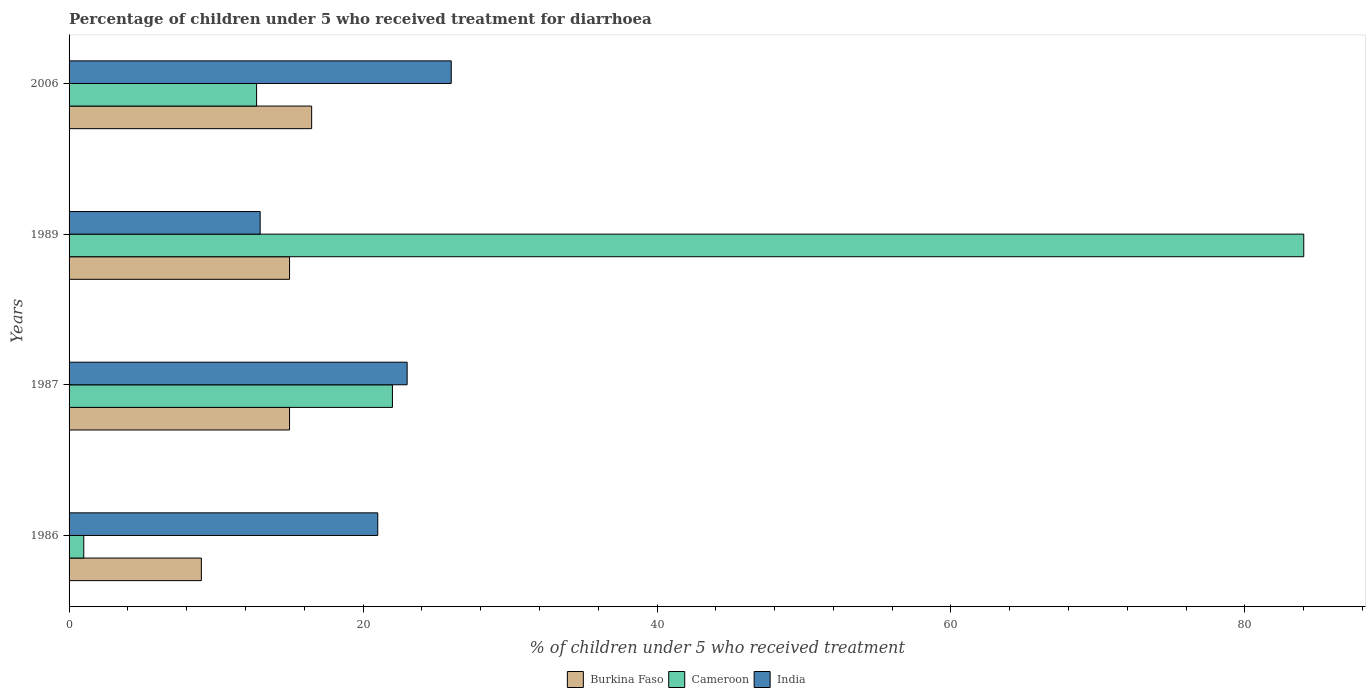Are the number of bars on each tick of the Y-axis equal?
Your answer should be very brief. Yes. How many bars are there on the 3rd tick from the bottom?
Provide a short and direct response. 3. In how many cases, is the number of bars for a given year not equal to the number of legend labels?
Ensure brevity in your answer.  0. Across all years, what is the maximum percentage of children who received treatment for diarrhoea  in Burkina Faso?
Keep it short and to the point. 16.5. Across all years, what is the minimum percentage of children who received treatment for diarrhoea  in Cameroon?
Offer a terse response. 1. In which year was the percentage of children who received treatment for diarrhoea  in India maximum?
Offer a very short reply. 2006. In which year was the percentage of children who received treatment for diarrhoea  in Cameroon minimum?
Provide a short and direct response. 1986. What is the difference between the percentage of children who received treatment for diarrhoea  in Cameroon in 1987 and that in 1989?
Keep it short and to the point. -62. What is the average percentage of children who received treatment for diarrhoea  in Burkina Faso per year?
Your answer should be very brief. 13.88. In how many years, is the percentage of children who received treatment for diarrhoea  in Cameroon greater than 32 %?
Offer a very short reply. 1. What is the ratio of the percentage of children who received treatment for diarrhoea  in Cameroon in 1987 to that in 2006?
Your answer should be compact. 1.72. Is the percentage of children who received treatment for diarrhoea  in Cameroon in 1987 less than that in 2006?
Provide a succinct answer. No. What is the difference between the highest and the second highest percentage of children who received treatment for diarrhoea  in Cameroon?
Make the answer very short. 62. What is the difference between the highest and the lowest percentage of children who received treatment for diarrhoea  in Burkina Faso?
Make the answer very short. 7.5. In how many years, is the percentage of children who received treatment for diarrhoea  in Cameroon greater than the average percentage of children who received treatment for diarrhoea  in Cameroon taken over all years?
Give a very brief answer. 1. What does the 2nd bar from the top in 1989 represents?
Give a very brief answer. Cameroon. What does the 2nd bar from the bottom in 2006 represents?
Ensure brevity in your answer.  Cameroon. Is it the case that in every year, the sum of the percentage of children who received treatment for diarrhoea  in Burkina Faso and percentage of children who received treatment for diarrhoea  in Cameroon is greater than the percentage of children who received treatment for diarrhoea  in India?
Give a very brief answer. No. Are the values on the major ticks of X-axis written in scientific E-notation?
Provide a short and direct response. No. Does the graph contain grids?
Provide a short and direct response. No. What is the title of the graph?
Your answer should be compact. Percentage of children under 5 who received treatment for diarrhoea. Does "Hong Kong" appear as one of the legend labels in the graph?
Give a very brief answer. No. What is the label or title of the X-axis?
Provide a short and direct response. % of children under 5 who received treatment. What is the % of children under 5 who received treatment in Burkina Faso in 1986?
Offer a very short reply. 9. What is the % of children under 5 who received treatment in Cameroon in 1986?
Make the answer very short. 1. What is the % of children under 5 who received treatment of India in 1986?
Give a very brief answer. 21. What is the % of children under 5 who received treatment of Cameroon in 1987?
Your answer should be very brief. 22. What is the % of children under 5 who received treatment of India in 1987?
Provide a succinct answer. 23. What is the % of children under 5 who received treatment in Burkina Faso in 1989?
Provide a short and direct response. 15. What is the % of children under 5 who received treatment of India in 1989?
Your response must be concise. 13. What is the % of children under 5 who received treatment of Burkina Faso in 2006?
Keep it short and to the point. 16.5. What is the % of children under 5 who received treatment of Cameroon in 2006?
Your answer should be very brief. 12.76. What is the % of children under 5 who received treatment in India in 2006?
Your answer should be very brief. 26. Across all years, what is the maximum % of children under 5 who received treatment of Burkina Faso?
Make the answer very short. 16.5. Across all years, what is the maximum % of children under 5 who received treatment in India?
Make the answer very short. 26. Across all years, what is the minimum % of children under 5 who received treatment in Burkina Faso?
Your answer should be compact. 9. Across all years, what is the minimum % of children under 5 who received treatment of Cameroon?
Provide a succinct answer. 1. Across all years, what is the minimum % of children under 5 who received treatment of India?
Give a very brief answer. 13. What is the total % of children under 5 who received treatment of Burkina Faso in the graph?
Your response must be concise. 55.5. What is the total % of children under 5 who received treatment in Cameroon in the graph?
Keep it short and to the point. 119.76. What is the total % of children under 5 who received treatment of India in the graph?
Provide a short and direct response. 83. What is the difference between the % of children under 5 who received treatment in Cameroon in 1986 and that in 1987?
Provide a succinct answer. -21. What is the difference between the % of children under 5 who received treatment in India in 1986 and that in 1987?
Your answer should be very brief. -2. What is the difference between the % of children under 5 who received treatment in Burkina Faso in 1986 and that in 1989?
Your answer should be compact. -6. What is the difference between the % of children under 5 who received treatment in Cameroon in 1986 and that in 1989?
Your answer should be very brief. -83. What is the difference between the % of children under 5 who received treatment in India in 1986 and that in 1989?
Give a very brief answer. 8. What is the difference between the % of children under 5 who received treatment in Burkina Faso in 1986 and that in 2006?
Ensure brevity in your answer.  -7.5. What is the difference between the % of children under 5 who received treatment in Cameroon in 1986 and that in 2006?
Give a very brief answer. -11.76. What is the difference between the % of children under 5 who received treatment in Burkina Faso in 1987 and that in 1989?
Provide a short and direct response. 0. What is the difference between the % of children under 5 who received treatment in Cameroon in 1987 and that in 1989?
Offer a very short reply. -62. What is the difference between the % of children under 5 who received treatment in Burkina Faso in 1987 and that in 2006?
Your response must be concise. -1.5. What is the difference between the % of children under 5 who received treatment of Cameroon in 1987 and that in 2006?
Provide a succinct answer. 9.24. What is the difference between the % of children under 5 who received treatment in India in 1987 and that in 2006?
Ensure brevity in your answer.  -3. What is the difference between the % of children under 5 who received treatment of Burkina Faso in 1989 and that in 2006?
Your answer should be very brief. -1.5. What is the difference between the % of children under 5 who received treatment of Cameroon in 1989 and that in 2006?
Give a very brief answer. 71.24. What is the difference between the % of children under 5 who received treatment in India in 1989 and that in 2006?
Ensure brevity in your answer.  -13. What is the difference between the % of children under 5 who received treatment of Burkina Faso in 1986 and the % of children under 5 who received treatment of India in 1987?
Make the answer very short. -14. What is the difference between the % of children under 5 who received treatment of Cameroon in 1986 and the % of children under 5 who received treatment of India in 1987?
Your answer should be compact. -22. What is the difference between the % of children under 5 who received treatment in Burkina Faso in 1986 and the % of children under 5 who received treatment in Cameroon in 1989?
Offer a terse response. -75. What is the difference between the % of children under 5 who received treatment of Burkina Faso in 1986 and the % of children under 5 who received treatment of Cameroon in 2006?
Ensure brevity in your answer.  -3.76. What is the difference between the % of children under 5 who received treatment in Cameroon in 1986 and the % of children under 5 who received treatment in India in 2006?
Ensure brevity in your answer.  -25. What is the difference between the % of children under 5 who received treatment in Burkina Faso in 1987 and the % of children under 5 who received treatment in Cameroon in 1989?
Your answer should be very brief. -69. What is the difference between the % of children under 5 who received treatment of Burkina Faso in 1987 and the % of children under 5 who received treatment of Cameroon in 2006?
Provide a short and direct response. 2.24. What is the difference between the % of children under 5 who received treatment in Burkina Faso in 1987 and the % of children under 5 who received treatment in India in 2006?
Your answer should be very brief. -11. What is the difference between the % of children under 5 who received treatment in Cameroon in 1987 and the % of children under 5 who received treatment in India in 2006?
Ensure brevity in your answer.  -4. What is the difference between the % of children under 5 who received treatment of Burkina Faso in 1989 and the % of children under 5 who received treatment of Cameroon in 2006?
Make the answer very short. 2.24. What is the difference between the % of children under 5 who received treatment of Burkina Faso in 1989 and the % of children under 5 who received treatment of India in 2006?
Your answer should be compact. -11. What is the difference between the % of children under 5 who received treatment of Cameroon in 1989 and the % of children under 5 who received treatment of India in 2006?
Give a very brief answer. 58. What is the average % of children under 5 who received treatment of Burkina Faso per year?
Provide a succinct answer. 13.88. What is the average % of children under 5 who received treatment in Cameroon per year?
Ensure brevity in your answer.  29.94. What is the average % of children under 5 who received treatment of India per year?
Offer a terse response. 20.75. In the year 1986, what is the difference between the % of children under 5 who received treatment in Burkina Faso and % of children under 5 who received treatment in India?
Keep it short and to the point. -12. In the year 1987, what is the difference between the % of children under 5 who received treatment in Burkina Faso and % of children under 5 who received treatment in India?
Offer a very short reply. -8. In the year 1989, what is the difference between the % of children under 5 who received treatment in Burkina Faso and % of children under 5 who received treatment in Cameroon?
Your response must be concise. -69. In the year 1989, what is the difference between the % of children under 5 who received treatment of Burkina Faso and % of children under 5 who received treatment of India?
Ensure brevity in your answer.  2. In the year 1989, what is the difference between the % of children under 5 who received treatment of Cameroon and % of children under 5 who received treatment of India?
Your answer should be very brief. 71. In the year 2006, what is the difference between the % of children under 5 who received treatment in Burkina Faso and % of children under 5 who received treatment in Cameroon?
Make the answer very short. 3.75. In the year 2006, what is the difference between the % of children under 5 who received treatment in Burkina Faso and % of children under 5 who received treatment in India?
Offer a very short reply. -9.5. In the year 2006, what is the difference between the % of children under 5 who received treatment in Cameroon and % of children under 5 who received treatment in India?
Provide a short and direct response. -13.24. What is the ratio of the % of children under 5 who received treatment of Burkina Faso in 1986 to that in 1987?
Keep it short and to the point. 0.6. What is the ratio of the % of children under 5 who received treatment in Cameroon in 1986 to that in 1987?
Provide a succinct answer. 0.05. What is the ratio of the % of children under 5 who received treatment in India in 1986 to that in 1987?
Provide a succinct answer. 0.91. What is the ratio of the % of children under 5 who received treatment in Burkina Faso in 1986 to that in 1989?
Provide a short and direct response. 0.6. What is the ratio of the % of children under 5 who received treatment of Cameroon in 1986 to that in 1989?
Offer a terse response. 0.01. What is the ratio of the % of children under 5 who received treatment in India in 1986 to that in 1989?
Give a very brief answer. 1.62. What is the ratio of the % of children under 5 who received treatment of Burkina Faso in 1986 to that in 2006?
Your response must be concise. 0.55. What is the ratio of the % of children under 5 who received treatment in Cameroon in 1986 to that in 2006?
Offer a very short reply. 0.08. What is the ratio of the % of children under 5 who received treatment in India in 1986 to that in 2006?
Offer a very short reply. 0.81. What is the ratio of the % of children under 5 who received treatment in Burkina Faso in 1987 to that in 1989?
Provide a short and direct response. 1. What is the ratio of the % of children under 5 who received treatment in Cameroon in 1987 to that in 1989?
Your answer should be very brief. 0.26. What is the ratio of the % of children under 5 who received treatment in India in 1987 to that in 1989?
Your response must be concise. 1.77. What is the ratio of the % of children under 5 who received treatment in Burkina Faso in 1987 to that in 2006?
Your answer should be compact. 0.91. What is the ratio of the % of children under 5 who received treatment in Cameroon in 1987 to that in 2006?
Ensure brevity in your answer.  1.72. What is the ratio of the % of children under 5 who received treatment of India in 1987 to that in 2006?
Offer a terse response. 0.88. What is the ratio of the % of children under 5 who received treatment in Burkina Faso in 1989 to that in 2006?
Make the answer very short. 0.91. What is the ratio of the % of children under 5 who received treatment in Cameroon in 1989 to that in 2006?
Provide a succinct answer. 6.58. What is the ratio of the % of children under 5 who received treatment of India in 1989 to that in 2006?
Your answer should be very brief. 0.5. What is the difference between the highest and the second highest % of children under 5 who received treatment in Burkina Faso?
Provide a succinct answer. 1.5. What is the difference between the highest and the second highest % of children under 5 who received treatment of Cameroon?
Make the answer very short. 62. What is the difference between the highest and the lowest % of children under 5 who received treatment in Burkina Faso?
Make the answer very short. 7.5. What is the difference between the highest and the lowest % of children under 5 who received treatment of India?
Ensure brevity in your answer.  13. 